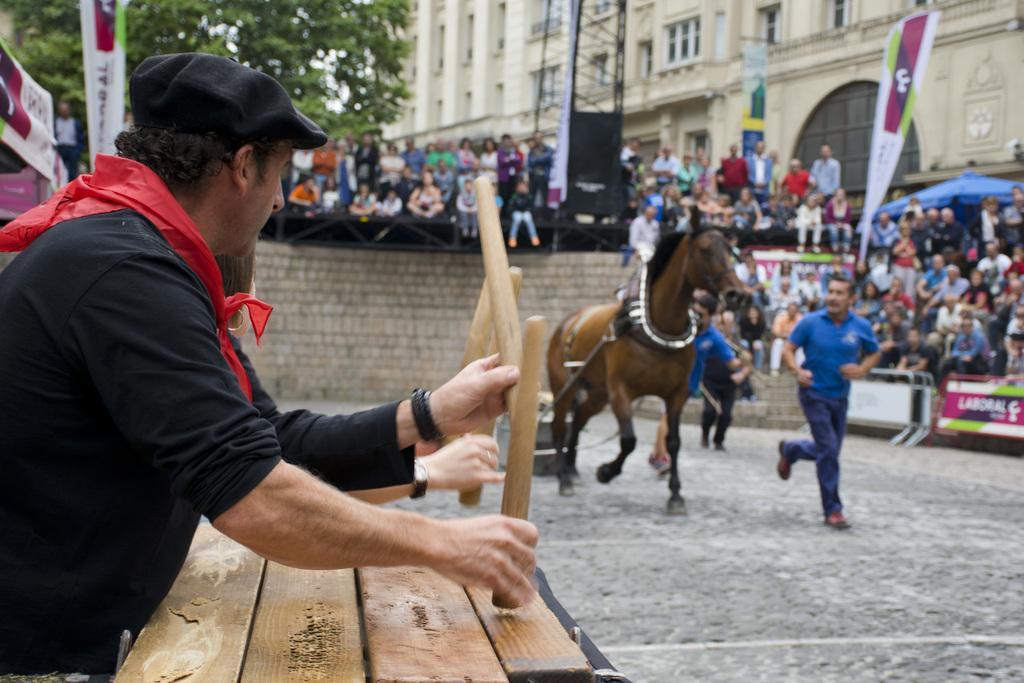Can you describe this image briefly? This is a picture where we can see a man holding a thing and a horse and the other man behind the horse and some people behind them. 